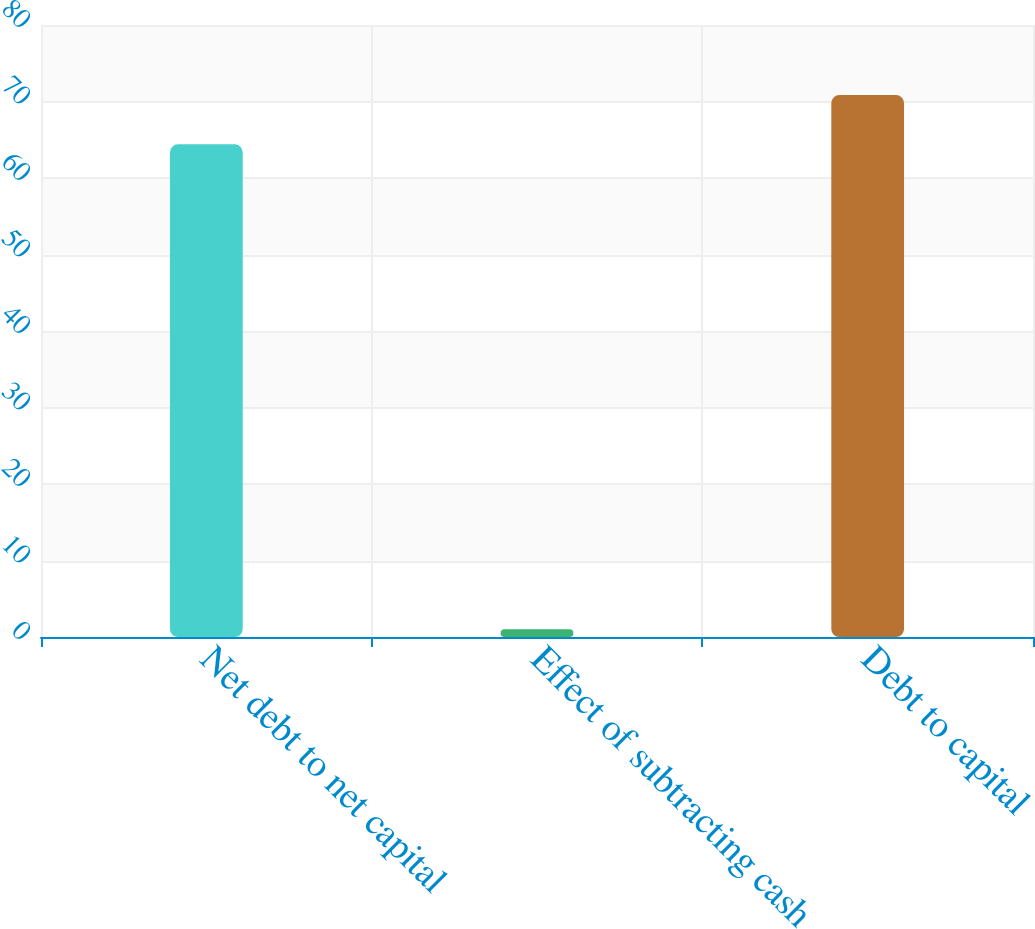Convert chart. <chart><loc_0><loc_0><loc_500><loc_500><bar_chart><fcel>Net debt to net capital<fcel>Effect of subtracting cash<fcel>Debt to capital<nl><fcel>64.4<fcel>1<fcel>70.84<nl></chart> 